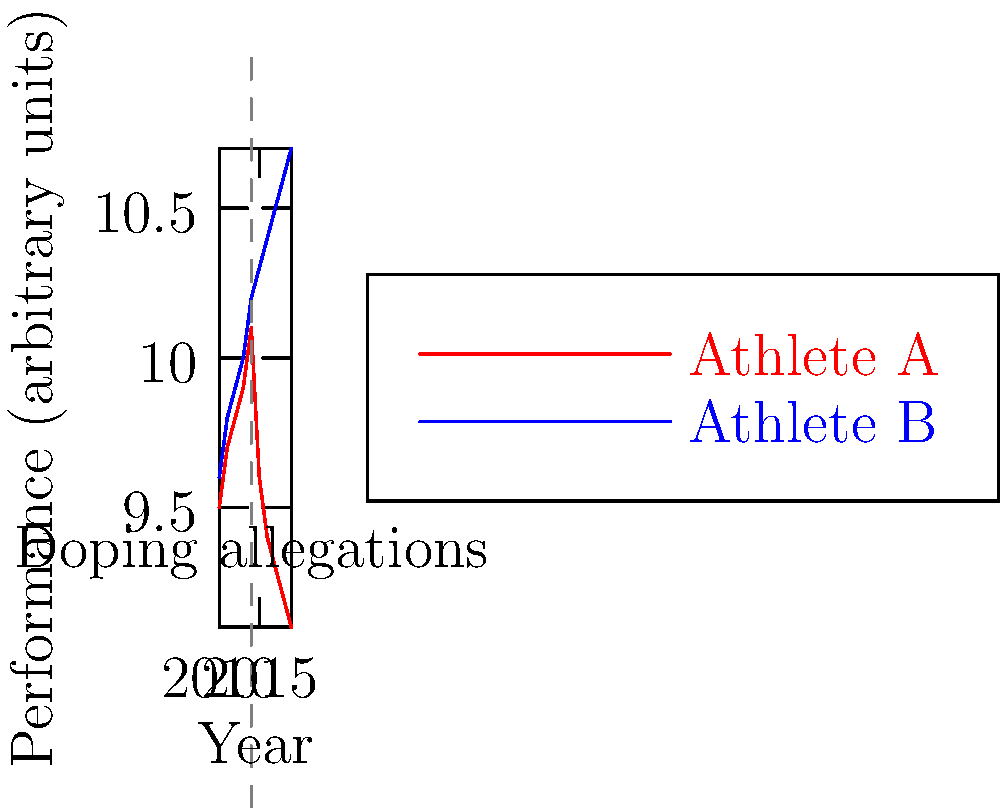Based on the line graph showing the performance of two athletes over a decade, what can be inferred about the impact of doping allegations that surfaced in 2014 on Athlete A's performance? To answer this question, we need to analyze the performance trends of Athlete A before and after the doping allegations in 2014:

1. Pre-2014 performance (2010-2014):
   - Athlete A's performance shows a steady increase from 9.5 to 10.1 units.

2. 2014 (Year of doping allegations):
   - Athlete A's performance peaks at 10.1 units.

3. Post-2014 performance (2015-2019):
   - There is a sharp decline in performance from 10.1 to 9.6 units in 2015.
   - The downward trend continues, reaching 9.1 units by 2019.

4. Comparison with Athlete B:
   - Athlete B's performance continues to improve consistently throughout the decade.
   - This contrasts sharply with Athlete A's decline after 2014.

5. Inference:
   - The sudden and sustained drop in Athlete A's performance after 2014 coincides with the doping allegations.
   - This suggests that the allegations may have had a significant negative impact on Athlete A's performance.
   - Possible reasons could include:
     a) Discontinuation of performance-enhancing substances
     b) Psychological impact of the allegations
     c) Increased scrutiny and testing

Given the data and the context of doping allegations, it can be inferred that the allegations likely had a substantial negative impact on Athlete A's performance.
Answer: Significant negative impact 